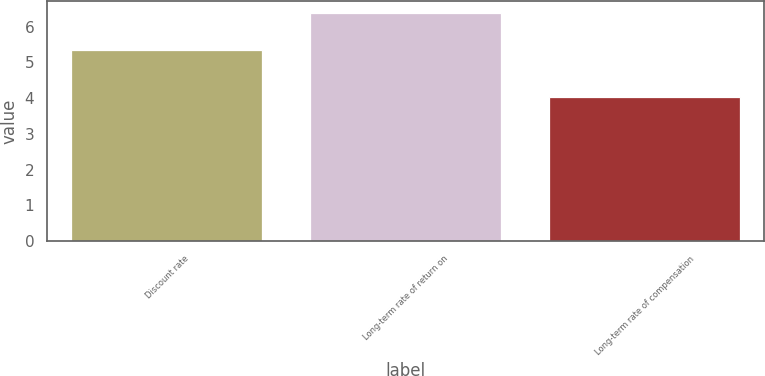<chart> <loc_0><loc_0><loc_500><loc_500><bar_chart><fcel>Discount rate<fcel>Long-term rate of return on<fcel>Long-term rate of compensation<nl><fcel>5.35<fcel>6.39<fcel>4.02<nl></chart> 